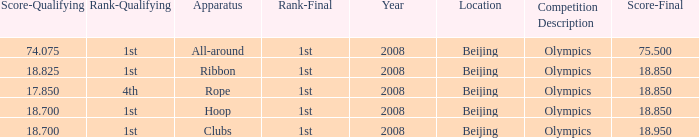What was her lowest final score with a qualifying score of 74.075? 75.5. 